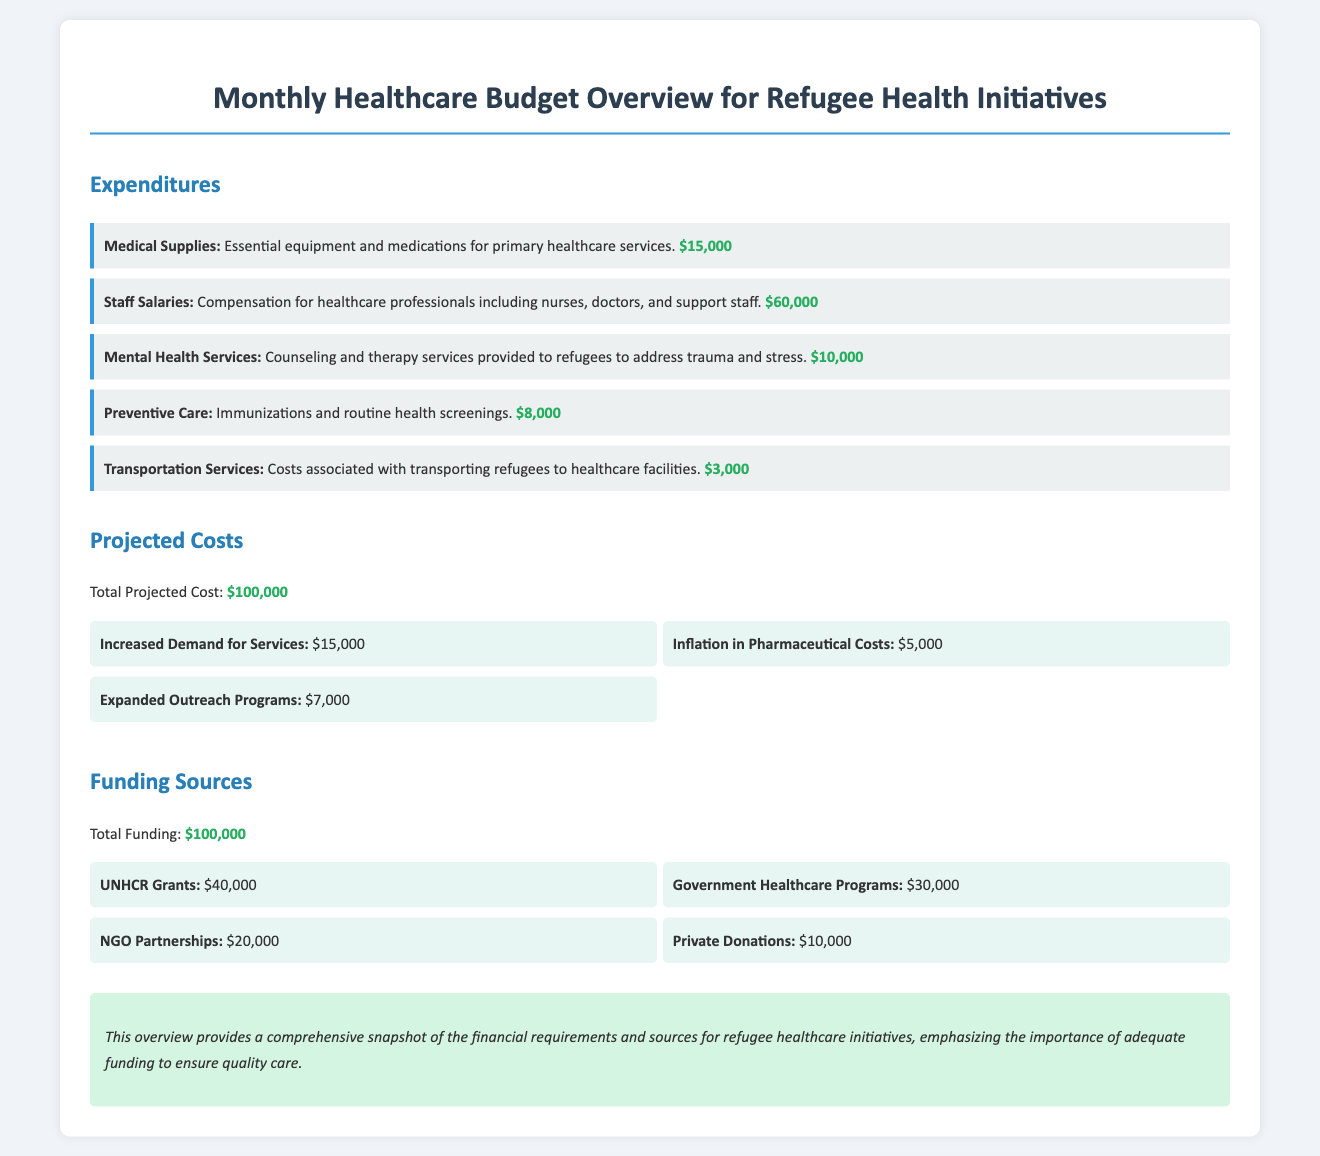What are the expenditures for medical supplies? The document lists the expenditures for medical supplies as essential equipment and medications for primary healthcare services.
Answer: $15,000 What is the total projected cost? The total projected cost is mentioned in the document and includes increased demand for services, inflation in pharmaceutical costs, and expanded outreach programs.
Answer: $100,000 How much funding comes from UNHCR grants? The document specifies the amount of funding from UNHCR grants.
Answer: $40,000 What is the expenditure on mental health services? The expenditure on mental health services is clearly stated in the document.
Answer: $10,000 What is the sum of the funding from government healthcare programs and NGO partnerships? The sum of funding from government healthcare programs and NGO partnerships can be calculated from the amounts listed in the document.
Answer: $50,000 How much is allocated for transportation services? The amount allocated for transportation services is provided in the expenditures section of the document.
Answer: $3,000 What type of services does the $10,000 for mental health cover? The document explains that the $10,000 for mental health covers counseling and therapy services for refugees.
Answer: Counseling and therapy services What is the total amount of funding from private donations? The document lists the total amount from private donations as part of the funding sources.
Answer: $10,000 What is emphasized in the conclusion of the document? The conclusion states the importance of adequate funding for refugee healthcare initiatives to ensure quality care.
Answer: Importance of adequate funding 